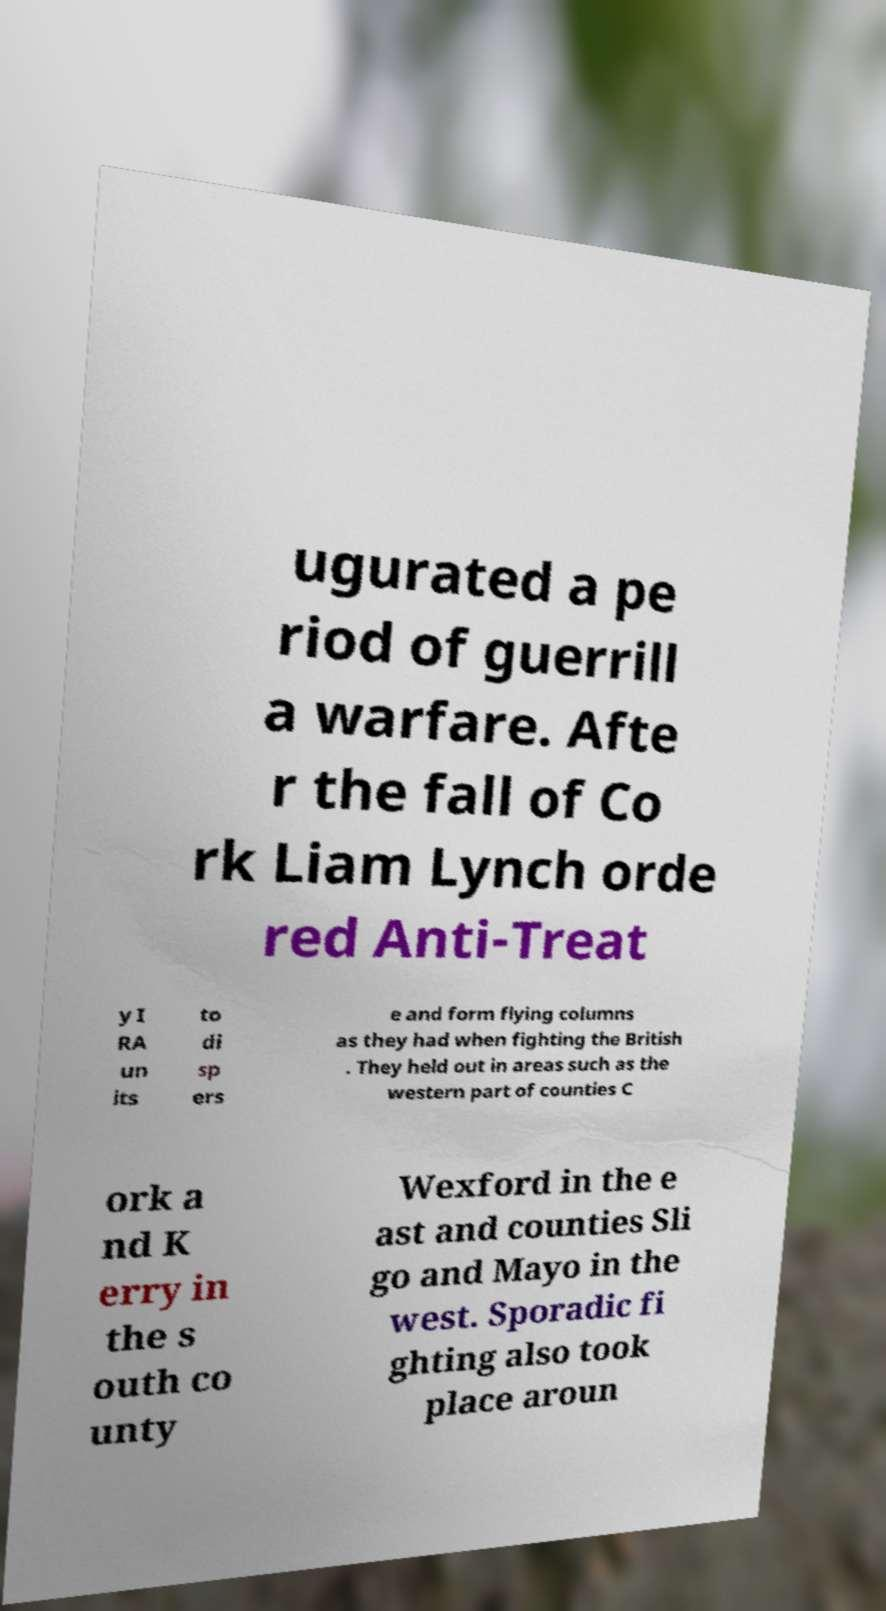Please identify and transcribe the text found in this image. ugurated a pe riod of guerrill a warfare. Afte r the fall of Co rk Liam Lynch orde red Anti-Treat y I RA un its to di sp ers e and form flying columns as they had when fighting the British . They held out in areas such as the western part of counties C ork a nd K erry in the s outh co unty Wexford in the e ast and counties Sli go and Mayo in the west. Sporadic fi ghting also took place aroun 